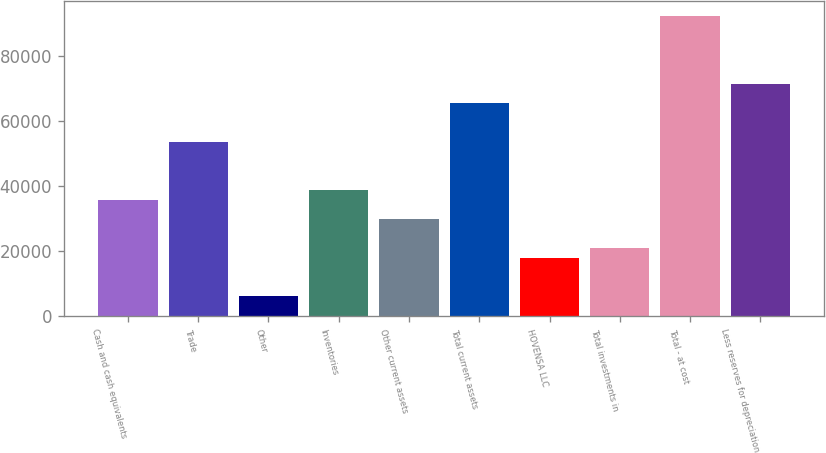Convert chart to OTSL. <chart><loc_0><loc_0><loc_500><loc_500><bar_chart><fcel>Cash and cash equivalents<fcel>Trade<fcel>Other<fcel>Inventories<fcel>Other current assets<fcel>Total current assets<fcel>HOVENSA LLC<fcel>Total investments in<fcel>Total - at cost<fcel>Less reserves for depreciation<nl><fcel>35816.4<fcel>53652.6<fcel>6089.4<fcel>38789.1<fcel>29871<fcel>65543.4<fcel>17980.2<fcel>20952.9<fcel>92297.7<fcel>71488.8<nl></chart> 